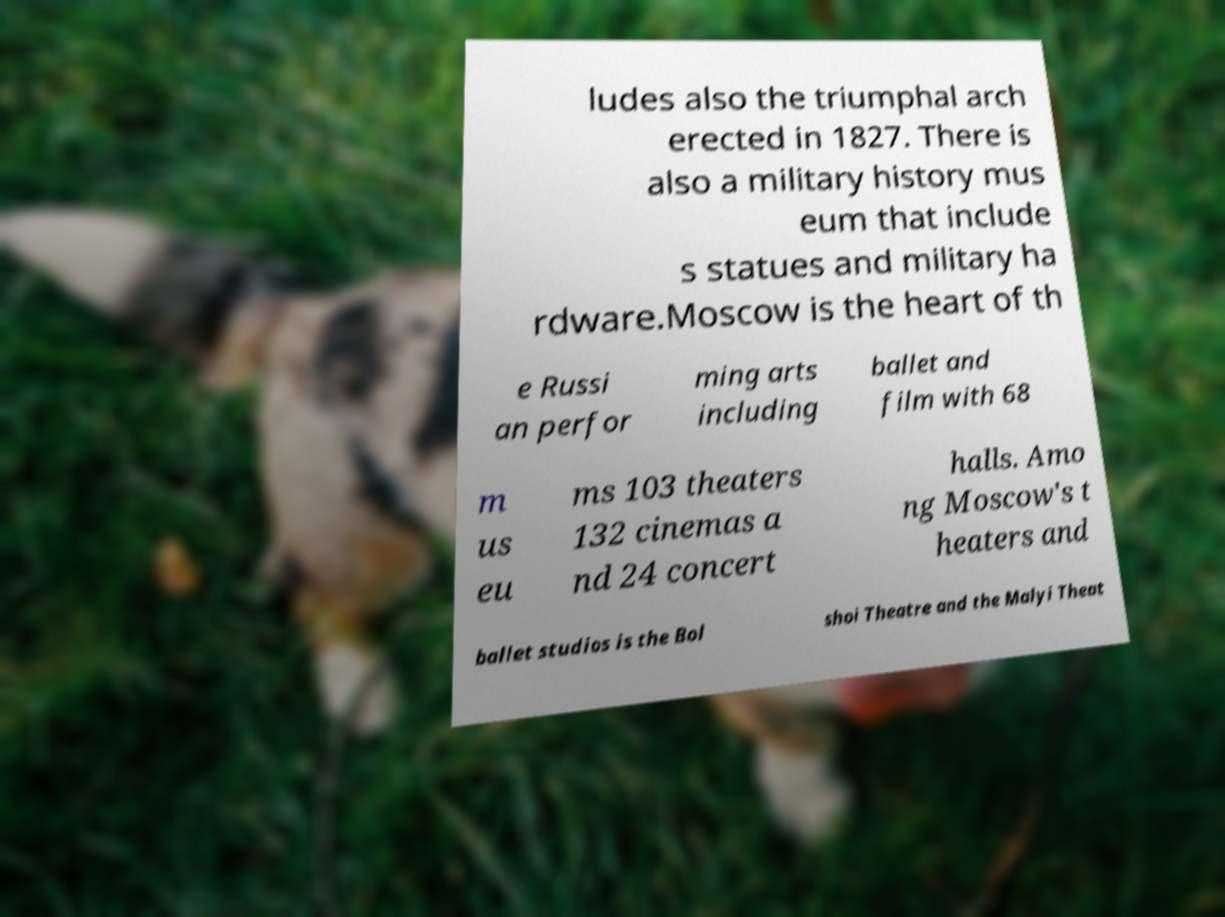There's text embedded in this image that I need extracted. Can you transcribe it verbatim? ludes also the triumphal arch erected in 1827. There is also a military history mus eum that include s statues and military ha rdware.Moscow is the heart of th e Russi an perfor ming arts including ballet and film with 68 m us eu ms 103 theaters 132 cinemas a nd 24 concert halls. Amo ng Moscow's t heaters and ballet studios is the Bol shoi Theatre and the Malyi Theat 